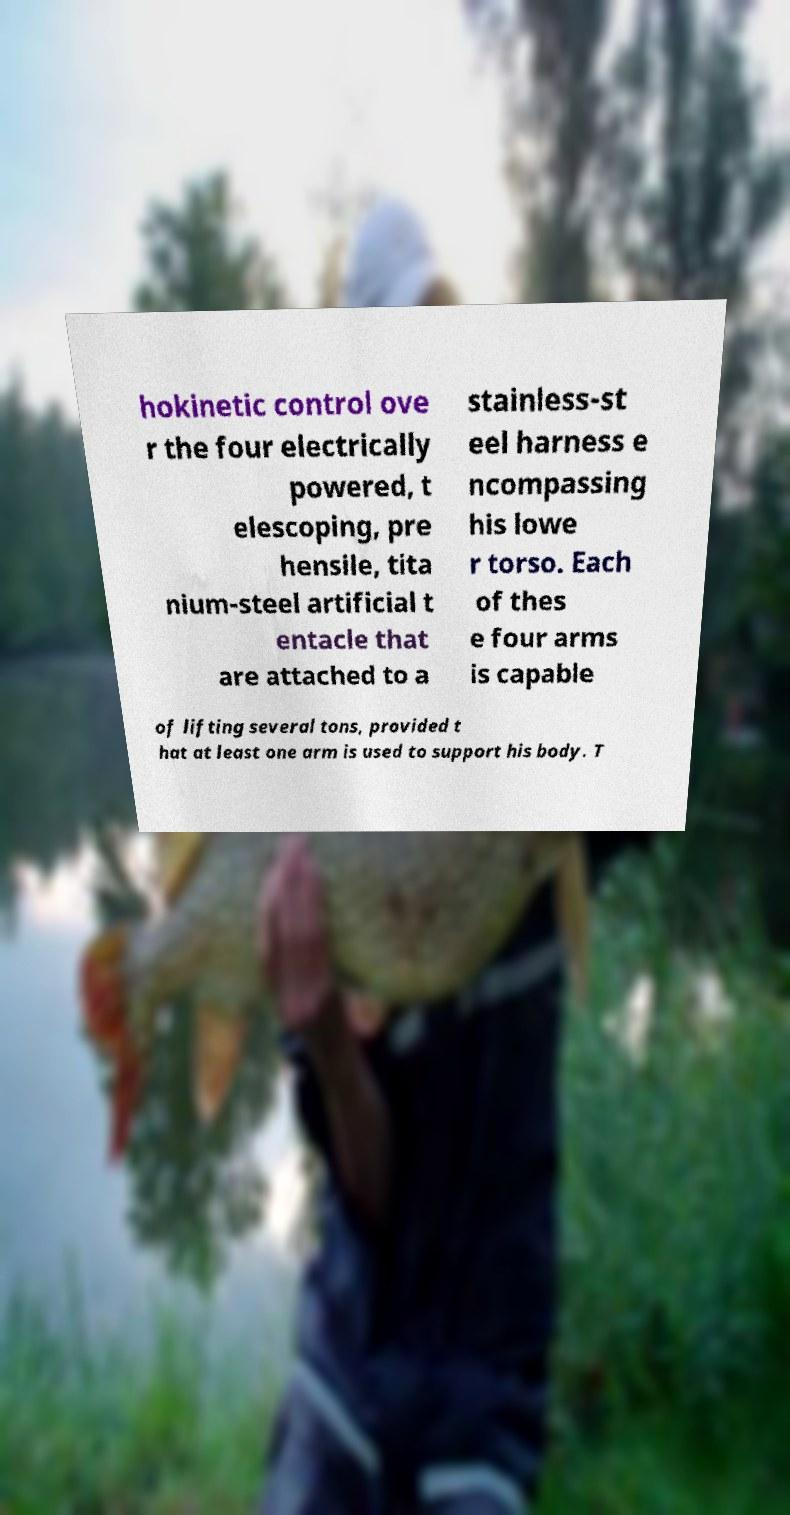For documentation purposes, I need the text within this image transcribed. Could you provide that? hokinetic control ove r the four electrically powered, t elescoping, pre hensile, tita nium-steel artificial t entacle that are attached to a stainless-st eel harness e ncompassing his lowe r torso. Each of thes e four arms is capable of lifting several tons, provided t hat at least one arm is used to support his body. T 